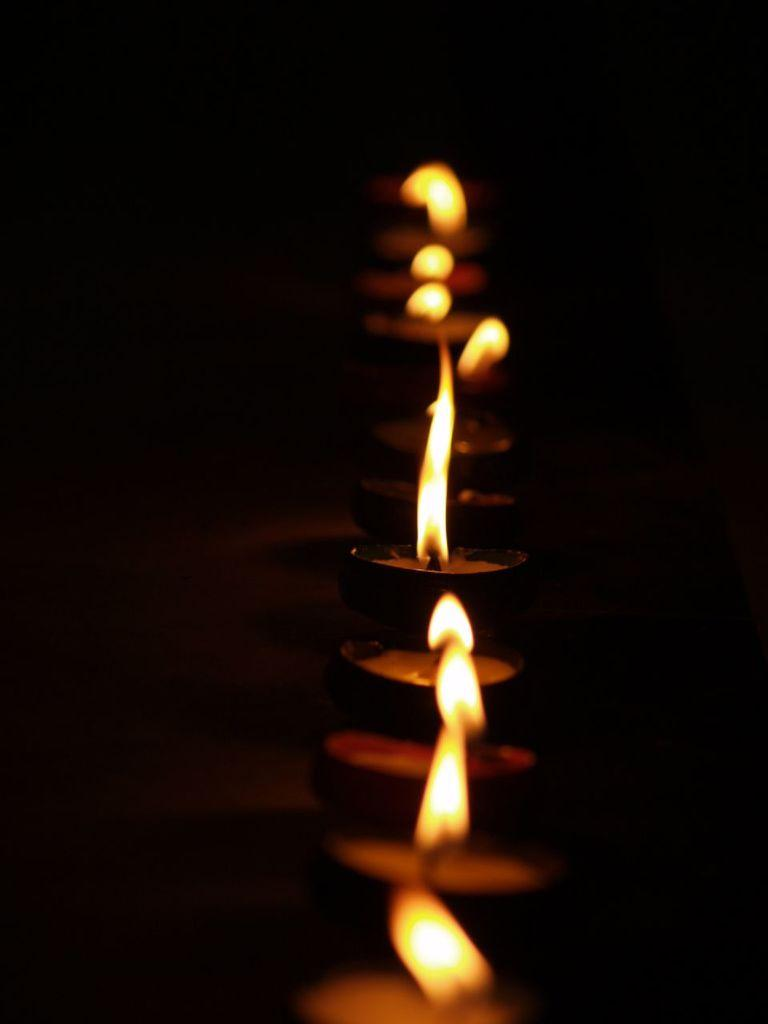What type of people are in the image? There is a group of divas in the image. What can be observed about the background of the image? The background of the image is dark. What scent can be detected from the divas in the image? There is no information about the scent of the divas in the image, as it is a visual medium. 